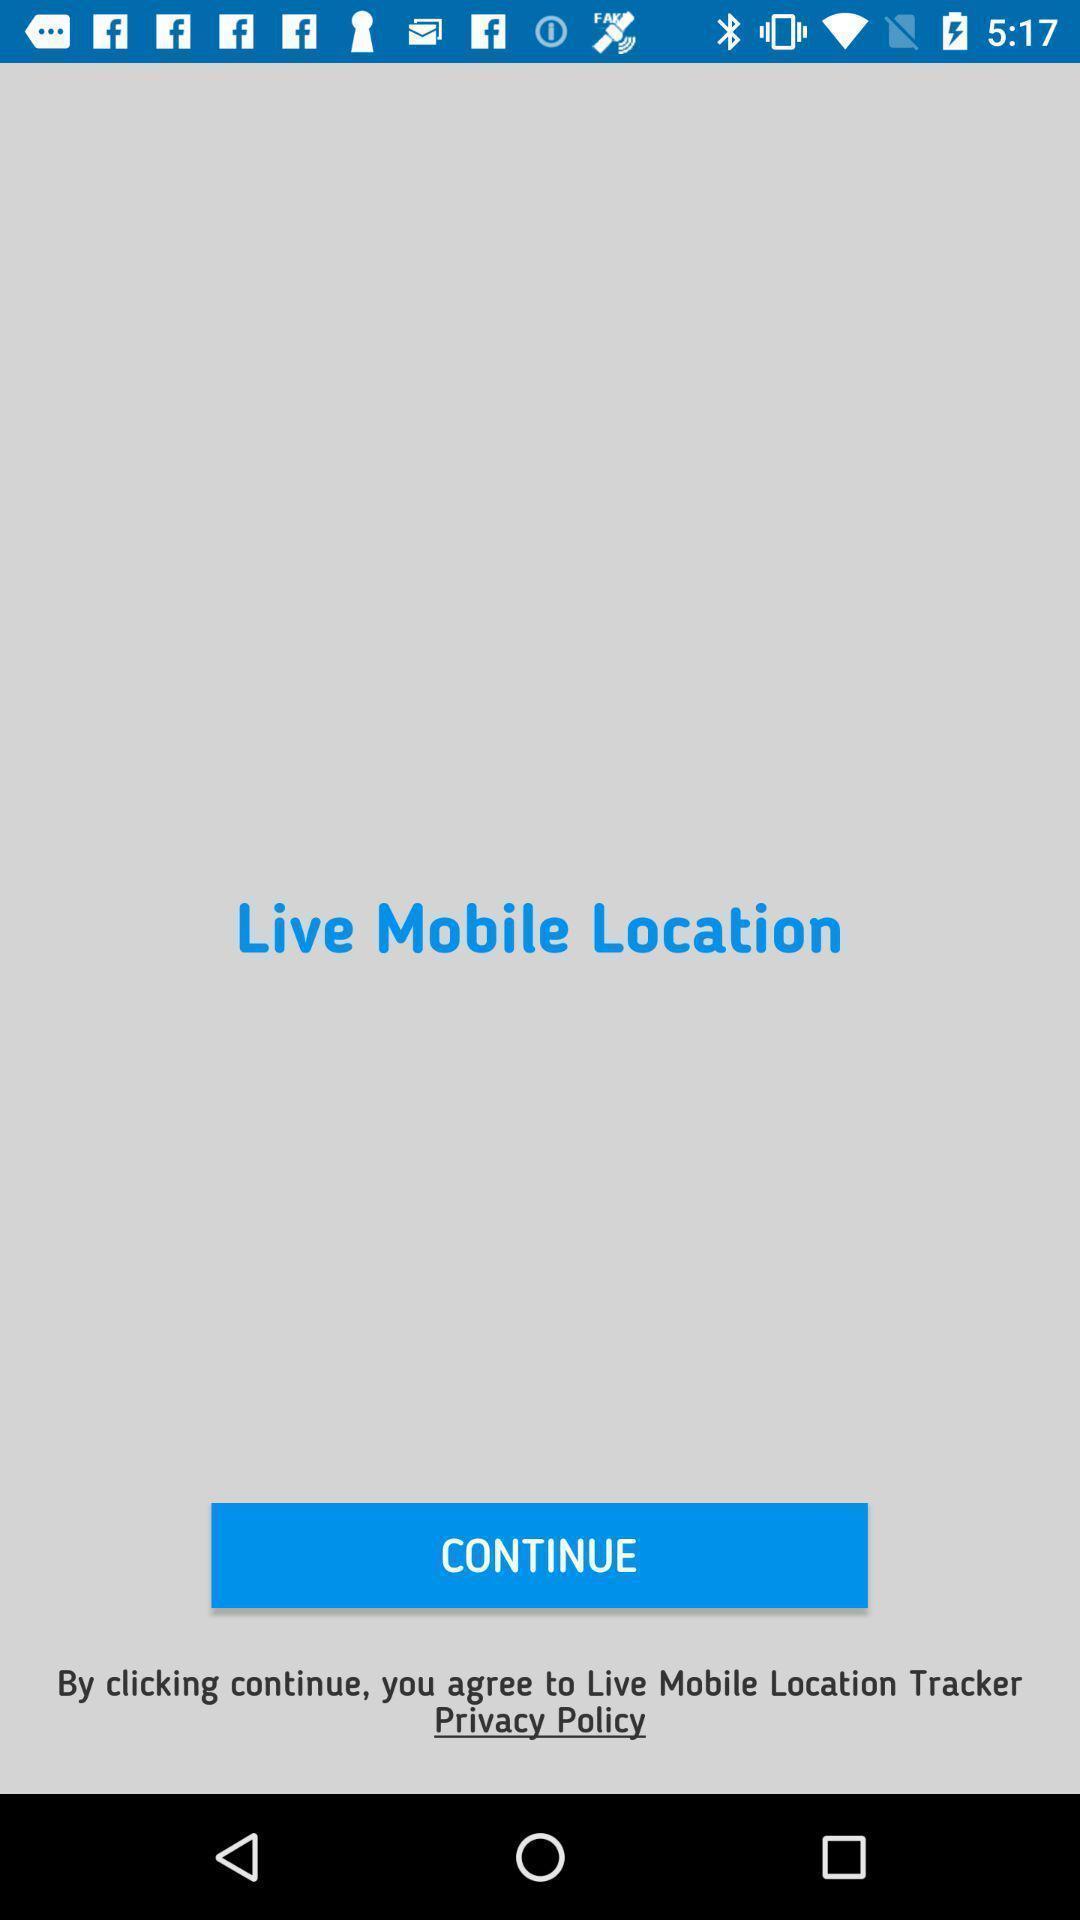Tell me about the visual elements in this screen capture. Starting page of a tracking app. 